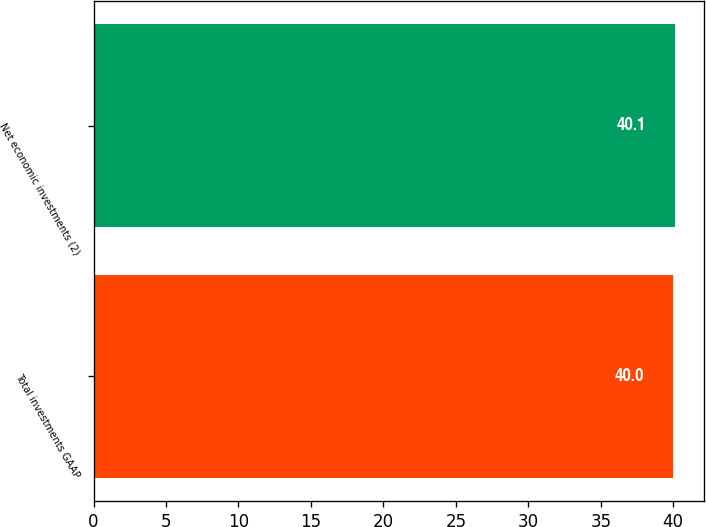<chart> <loc_0><loc_0><loc_500><loc_500><bar_chart><fcel>Total investments GAAP<fcel>Net economic investments (2)<nl><fcel>40<fcel>40.1<nl></chart> 